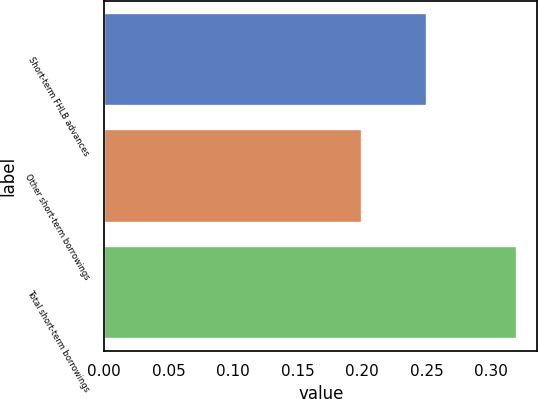Convert chart. <chart><loc_0><loc_0><loc_500><loc_500><bar_chart><fcel>Short-term FHLB advances<fcel>Other short-term borrowings<fcel>Total short-term borrowings<nl><fcel>0.25<fcel>0.2<fcel>0.32<nl></chart> 